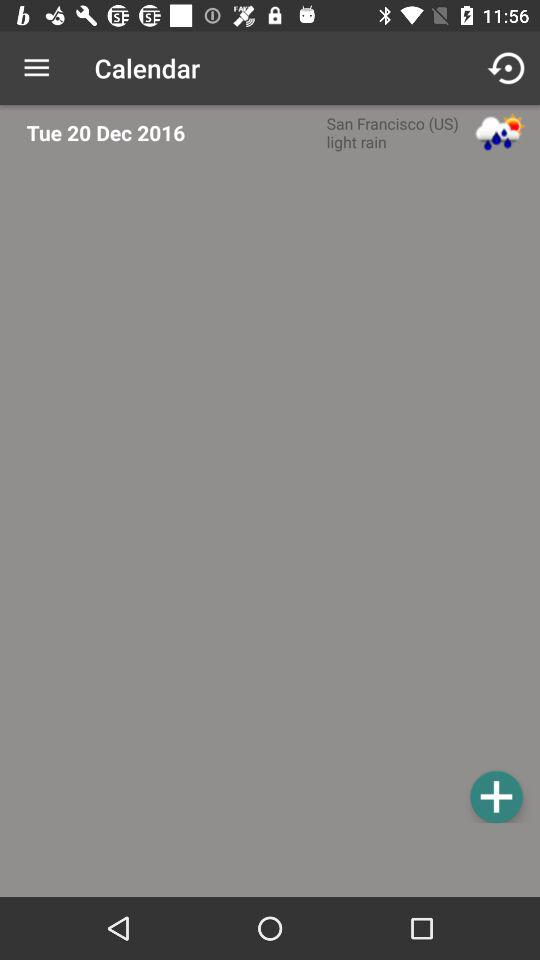What is the weather like? The weather is like "light rain". 